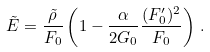<formula> <loc_0><loc_0><loc_500><loc_500>\tilde { E } = \frac { \tilde { \rho } } { F _ { 0 } } \left ( 1 - \frac { \alpha } { 2 G _ { 0 } } \frac { ( F _ { 0 } ^ { \prime } ) ^ { 2 } } { F _ { 0 } } \right ) \, .</formula> 